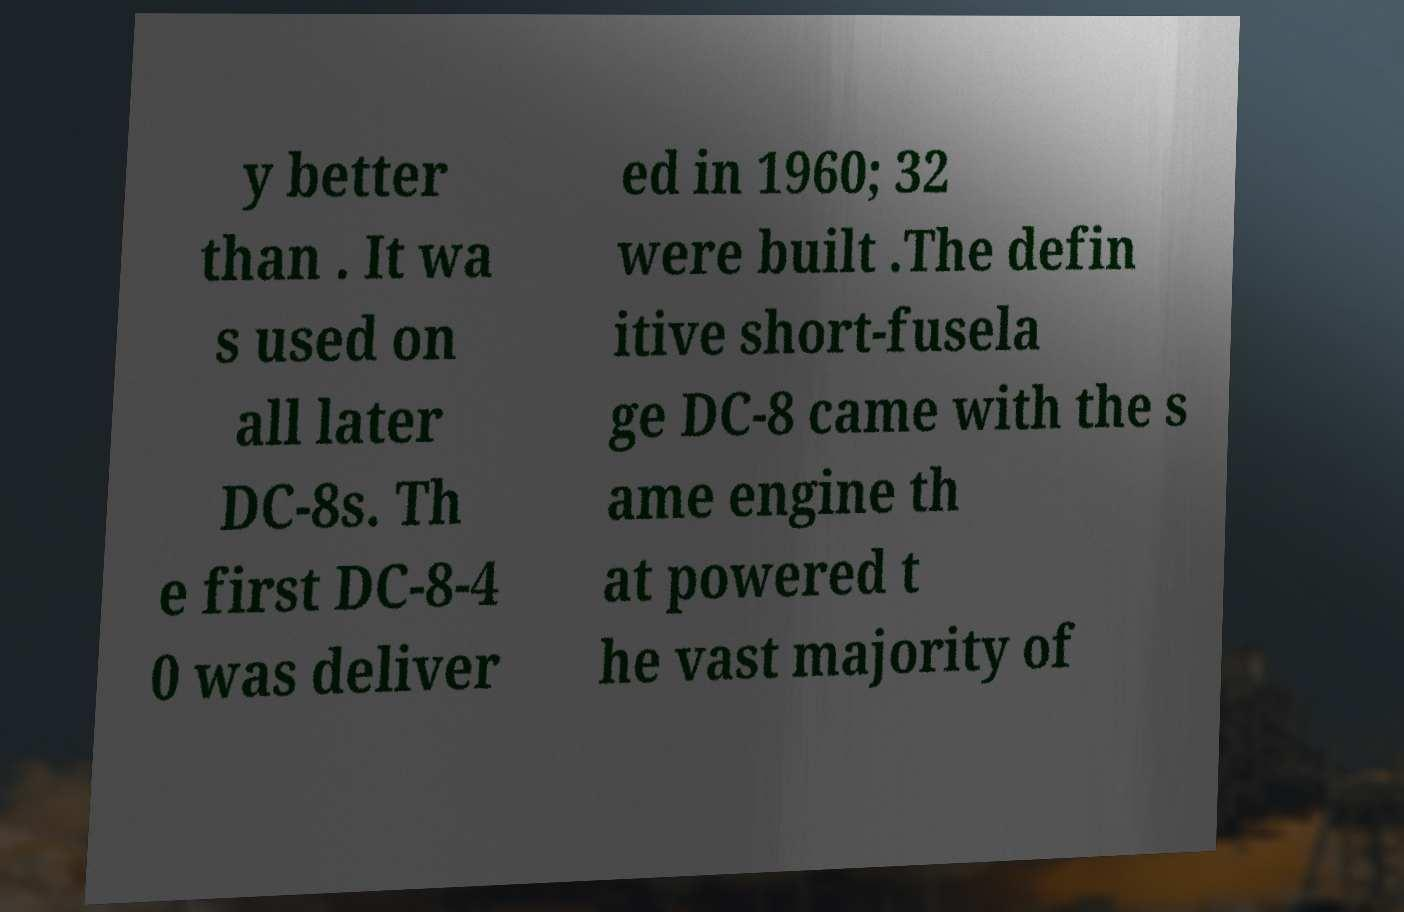Can you accurately transcribe the text from the provided image for me? y better than . It wa s used on all later DC-8s. Th e first DC-8-4 0 was deliver ed in 1960; 32 were built .The defin itive short-fusela ge DC-8 came with the s ame engine th at powered t he vast majority of 